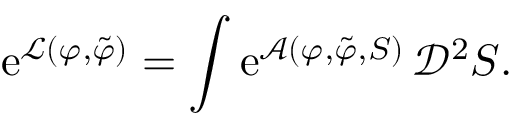<formula> <loc_0><loc_0><loc_500><loc_500>e ^ { \mathcal { L } ( \varphi , \tilde { \varphi } ) } = \int e ^ { \mathcal { A } ( \varphi , \tilde { \varphi } , S ) } \, \ m a t h s c r { D } ^ { 2 } S .</formula> 